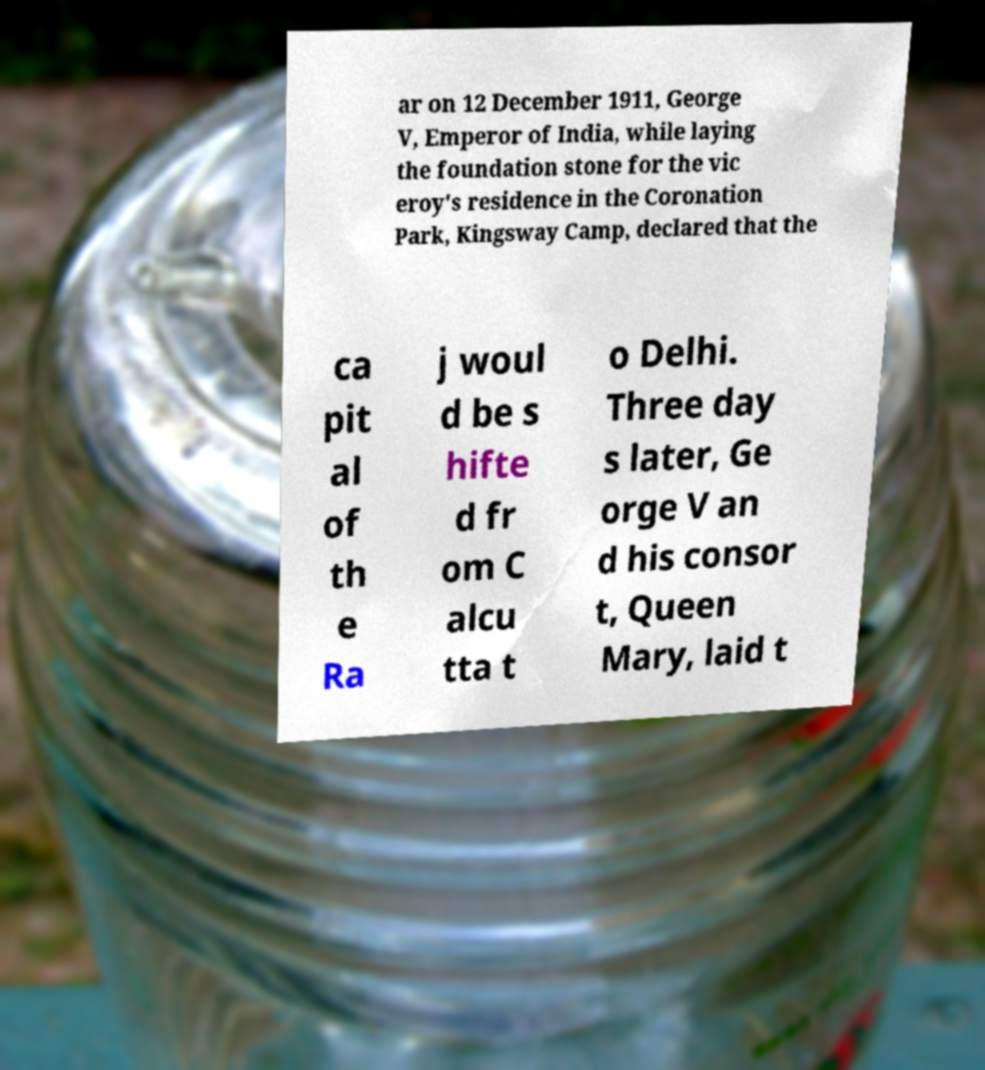Please identify and transcribe the text found in this image. ar on 12 December 1911, George V, Emperor of India, while laying the foundation stone for the vic eroy's residence in the Coronation Park, Kingsway Camp, declared that the ca pit al of th e Ra j woul d be s hifte d fr om C alcu tta t o Delhi. Three day s later, Ge orge V an d his consor t, Queen Mary, laid t 